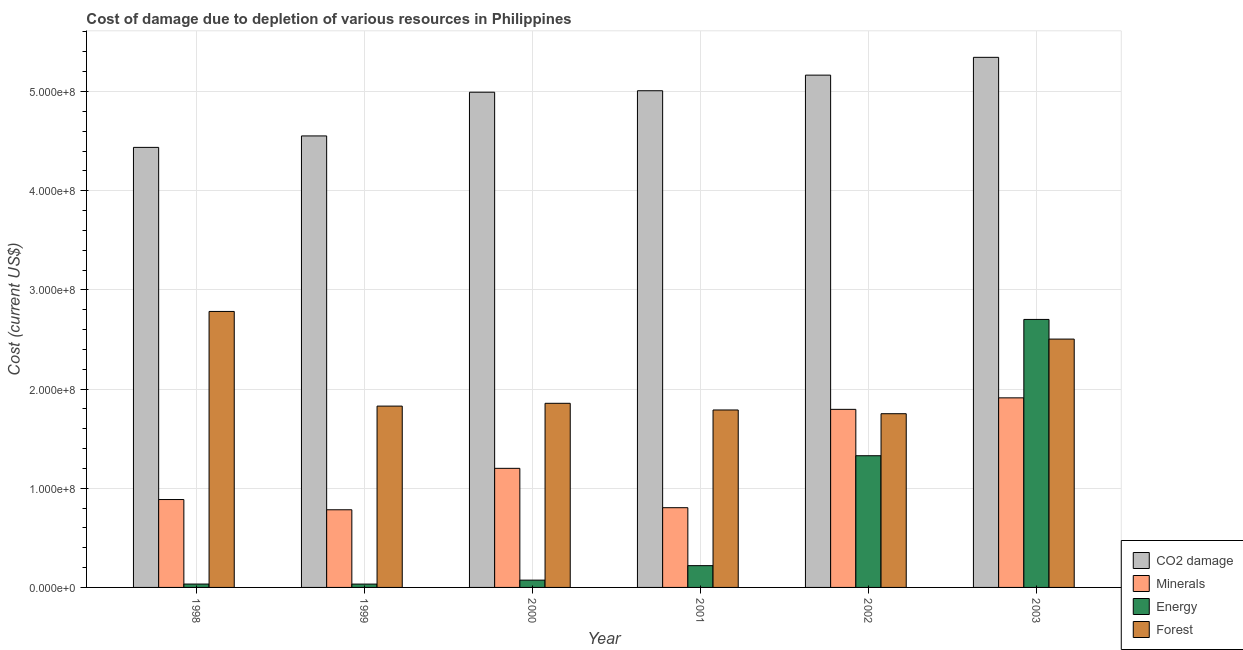How many different coloured bars are there?
Your answer should be very brief. 4. How many bars are there on the 2nd tick from the left?
Your answer should be compact. 4. What is the cost of damage due to depletion of coal in 2002?
Make the answer very short. 5.16e+08. Across all years, what is the maximum cost of damage due to depletion of energy?
Ensure brevity in your answer.  2.70e+08. Across all years, what is the minimum cost of damage due to depletion of coal?
Offer a terse response. 4.44e+08. In which year was the cost of damage due to depletion of forests minimum?
Your answer should be compact. 2002. What is the total cost of damage due to depletion of coal in the graph?
Your answer should be compact. 2.95e+09. What is the difference between the cost of damage due to depletion of forests in 2002 and that in 2003?
Offer a terse response. -7.52e+07. What is the difference between the cost of damage due to depletion of forests in 2003 and the cost of damage due to depletion of energy in 1998?
Provide a succinct answer. -2.79e+07. What is the average cost of damage due to depletion of coal per year?
Give a very brief answer. 4.92e+08. What is the ratio of the cost of damage due to depletion of coal in 2001 to that in 2002?
Your answer should be compact. 0.97. Is the cost of damage due to depletion of forests in 1998 less than that in 2003?
Give a very brief answer. No. Is the difference between the cost of damage due to depletion of forests in 2001 and 2002 greater than the difference between the cost of damage due to depletion of coal in 2001 and 2002?
Provide a short and direct response. No. What is the difference between the highest and the second highest cost of damage due to depletion of minerals?
Provide a succinct answer. 1.16e+07. What is the difference between the highest and the lowest cost of damage due to depletion of coal?
Your answer should be very brief. 9.08e+07. In how many years, is the cost of damage due to depletion of coal greater than the average cost of damage due to depletion of coal taken over all years?
Provide a short and direct response. 4. What does the 3rd bar from the left in 1999 represents?
Ensure brevity in your answer.  Energy. What does the 3rd bar from the right in 2001 represents?
Your answer should be compact. Minerals. Is it the case that in every year, the sum of the cost of damage due to depletion of coal and cost of damage due to depletion of minerals is greater than the cost of damage due to depletion of energy?
Your answer should be compact. Yes. Are the values on the major ticks of Y-axis written in scientific E-notation?
Your response must be concise. Yes. How are the legend labels stacked?
Keep it short and to the point. Vertical. What is the title of the graph?
Ensure brevity in your answer.  Cost of damage due to depletion of various resources in Philippines . Does "Fiscal policy" appear as one of the legend labels in the graph?
Keep it short and to the point. No. What is the label or title of the X-axis?
Provide a succinct answer. Year. What is the label or title of the Y-axis?
Keep it short and to the point. Cost (current US$). What is the Cost (current US$) in CO2 damage in 1998?
Offer a very short reply. 4.44e+08. What is the Cost (current US$) of Minerals in 1998?
Make the answer very short. 8.86e+07. What is the Cost (current US$) in Energy in 1998?
Your answer should be very brief. 3.40e+06. What is the Cost (current US$) of Forest in 1998?
Your response must be concise. 2.78e+08. What is the Cost (current US$) in CO2 damage in 1999?
Provide a short and direct response. 4.55e+08. What is the Cost (current US$) of Minerals in 1999?
Offer a very short reply. 7.83e+07. What is the Cost (current US$) in Energy in 1999?
Offer a very short reply. 3.37e+06. What is the Cost (current US$) of Forest in 1999?
Offer a terse response. 1.83e+08. What is the Cost (current US$) of CO2 damage in 2000?
Your response must be concise. 4.99e+08. What is the Cost (current US$) of Minerals in 2000?
Keep it short and to the point. 1.20e+08. What is the Cost (current US$) of Energy in 2000?
Provide a short and direct response. 7.35e+06. What is the Cost (current US$) of Forest in 2000?
Your response must be concise. 1.86e+08. What is the Cost (current US$) of CO2 damage in 2001?
Provide a short and direct response. 5.01e+08. What is the Cost (current US$) in Minerals in 2001?
Provide a succinct answer. 8.04e+07. What is the Cost (current US$) in Energy in 2001?
Ensure brevity in your answer.  2.20e+07. What is the Cost (current US$) in Forest in 2001?
Your answer should be compact. 1.79e+08. What is the Cost (current US$) of CO2 damage in 2002?
Offer a terse response. 5.16e+08. What is the Cost (current US$) of Minerals in 2002?
Ensure brevity in your answer.  1.80e+08. What is the Cost (current US$) in Energy in 2002?
Your answer should be very brief. 1.33e+08. What is the Cost (current US$) of Forest in 2002?
Provide a short and direct response. 1.75e+08. What is the Cost (current US$) in CO2 damage in 2003?
Keep it short and to the point. 5.34e+08. What is the Cost (current US$) of Minerals in 2003?
Your response must be concise. 1.91e+08. What is the Cost (current US$) of Energy in 2003?
Your response must be concise. 2.70e+08. What is the Cost (current US$) in Forest in 2003?
Keep it short and to the point. 2.50e+08. Across all years, what is the maximum Cost (current US$) in CO2 damage?
Keep it short and to the point. 5.34e+08. Across all years, what is the maximum Cost (current US$) in Minerals?
Offer a terse response. 1.91e+08. Across all years, what is the maximum Cost (current US$) in Energy?
Ensure brevity in your answer.  2.70e+08. Across all years, what is the maximum Cost (current US$) in Forest?
Your answer should be compact. 2.78e+08. Across all years, what is the minimum Cost (current US$) of CO2 damage?
Provide a short and direct response. 4.44e+08. Across all years, what is the minimum Cost (current US$) in Minerals?
Make the answer very short. 7.83e+07. Across all years, what is the minimum Cost (current US$) of Energy?
Give a very brief answer. 3.37e+06. Across all years, what is the minimum Cost (current US$) in Forest?
Offer a terse response. 1.75e+08. What is the total Cost (current US$) of CO2 damage in the graph?
Make the answer very short. 2.95e+09. What is the total Cost (current US$) of Minerals in the graph?
Keep it short and to the point. 7.38e+08. What is the total Cost (current US$) of Energy in the graph?
Ensure brevity in your answer.  4.39e+08. What is the total Cost (current US$) in Forest in the graph?
Provide a short and direct response. 1.25e+09. What is the difference between the Cost (current US$) of CO2 damage in 1998 and that in 1999?
Keep it short and to the point. -1.16e+07. What is the difference between the Cost (current US$) in Minerals in 1998 and that in 1999?
Provide a short and direct response. 1.03e+07. What is the difference between the Cost (current US$) of Energy in 1998 and that in 1999?
Your answer should be very brief. 3.30e+04. What is the difference between the Cost (current US$) of Forest in 1998 and that in 1999?
Provide a short and direct response. 9.54e+07. What is the difference between the Cost (current US$) of CO2 damage in 1998 and that in 2000?
Ensure brevity in your answer.  -5.56e+07. What is the difference between the Cost (current US$) of Minerals in 1998 and that in 2000?
Ensure brevity in your answer.  -3.15e+07. What is the difference between the Cost (current US$) of Energy in 1998 and that in 2000?
Offer a terse response. -3.95e+06. What is the difference between the Cost (current US$) of Forest in 1998 and that in 2000?
Your answer should be very brief. 9.26e+07. What is the difference between the Cost (current US$) in CO2 damage in 1998 and that in 2001?
Keep it short and to the point. -5.71e+07. What is the difference between the Cost (current US$) in Minerals in 1998 and that in 2001?
Your answer should be very brief. 8.23e+06. What is the difference between the Cost (current US$) of Energy in 1998 and that in 2001?
Give a very brief answer. -1.86e+07. What is the difference between the Cost (current US$) of Forest in 1998 and that in 2001?
Offer a very short reply. 9.93e+07. What is the difference between the Cost (current US$) in CO2 damage in 1998 and that in 2002?
Make the answer very short. -7.28e+07. What is the difference between the Cost (current US$) of Minerals in 1998 and that in 2002?
Ensure brevity in your answer.  -9.09e+07. What is the difference between the Cost (current US$) in Energy in 1998 and that in 2002?
Offer a terse response. -1.29e+08. What is the difference between the Cost (current US$) of Forest in 1998 and that in 2002?
Your answer should be compact. 1.03e+08. What is the difference between the Cost (current US$) of CO2 damage in 1998 and that in 2003?
Provide a succinct answer. -9.08e+07. What is the difference between the Cost (current US$) in Minerals in 1998 and that in 2003?
Provide a succinct answer. -1.03e+08. What is the difference between the Cost (current US$) of Energy in 1998 and that in 2003?
Provide a succinct answer. -2.67e+08. What is the difference between the Cost (current US$) in Forest in 1998 and that in 2003?
Your response must be concise. 2.79e+07. What is the difference between the Cost (current US$) of CO2 damage in 1999 and that in 2000?
Give a very brief answer. -4.41e+07. What is the difference between the Cost (current US$) in Minerals in 1999 and that in 2000?
Your answer should be very brief. -4.18e+07. What is the difference between the Cost (current US$) in Energy in 1999 and that in 2000?
Provide a succinct answer. -3.98e+06. What is the difference between the Cost (current US$) of Forest in 1999 and that in 2000?
Ensure brevity in your answer.  -2.81e+06. What is the difference between the Cost (current US$) in CO2 damage in 1999 and that in 2001?
Offer a terse response. -4.56e+07. What is the difference between the Cost (current US$) in Minerals in 1999 and that in 2001?
Offer a very short reply. -2.09e+06. What is the difference between the Cost (current US$) of Energy in 1999 and that in 2001?
Your response must be concise. -1.86e+07. What is the difference between the Cost (current US$) in Forest in 1999 and that in 2001?
Your response must be concise. 3.92e+06. What is the difference between the Cost (current US$) of CO2 damage in 1999 and that in 2002?
Offer a terse response. -6.13e+07. What is the difference between the Cost (current US$) in Minerals in 1999 and that in 2002?
Offer a terse response. -1.01e+08. What is the difference between the Cost (current US$) of Energy in 1999 and that in 2002?
Your response must be concise. -1.29e+08. What is the difference between the Cost (current US$) in Forest in 1999 and that in 2002?
Offer a terse response. 7.68e+06. What is the difference between the Cost (current US$) of CO2 damage in 1999 and that in 2003?
Give a very brief answer. -7.92e+07. What is the difference between the Cost (current US$) in Minerals in 1999 and that in 2003?
Provide a short and direct response. -1.13e+08. What is the difference between the Cost (current US$) of Energy in 1999 and that in 2003?
Ensure brevity in your answer.  -2.67e+08. What is the difference between the Cost (current US$) of Forest in 1999 and that in 2003?
Provide a short and direct response. -6.76e+07. What is the difference between the Cost (current US$) of CO2 damage in 2000 and that in 2001?
Keep it short and to the point. -1.48e+06. What is the difference between the Cost (current US$) in Minerals in 2000 and that in 2001?
Your response must be concise. 3.97e+07. What is the difference between the Cost (current US$) in Energy in 2000 and that in 2001?
Your answer should be compact. -1.46e+07. What is the difference between the Cost (current US$) in Forest in 2000 and that in 2001?
Make the answer very short. 6.73e+06. What is the difference between the Cost (current US$) in CO2 damage in 2000 and that in 2002?
Give a very brief answer. -1.72e+07. What is the difference between the Cost (current US$) in Minerals in 2000 and that in 2002?
Your answer should be very brief. -5.95e+07. What is the difference between the Cost (current US$) of Energy in 2000 and that in 2002?
Your response must be concise. -1.25e+08. What is the difference between the Cost (current US$) of Forest in 2000 and that in 2002?
Your answer should be very brief. 1.05e+07. What is the difference between the Cost (current US$) of CO2 damage in 2000 and that in 2003?
Offer a terse response. -3.52e+07. What is the difference between the Cost (current US$) of Minerals in 2000 and that in 2003?
Give a very brief answer. -7.11e+07. What is the difference between the Cost (current US$) in Energy in 2000 and that in 2003?
Provide a succinct answer. -2.63e+08. What is the difference between the Cost (current US$) in Forest in 2000 and that in 2003?
Provide a succinct answer. -6.47e+07. What is the difference between the Cost (current US$) of CO2 damage in 2001 and that in 2002?
Provide a succinct answer. -1.57e+07. What is the difference between the Cost (current US$) in Minerals in 2001 and that in 2002?
Your answer should be compact. -9.92e+07. What is the difference between the Cost (current US$) of Energy in 2001 and that in 2002?
Offer a very short reply. -1.11e+08. What is the difference between the Cost (current US$) of Forest in 2001 and that in 2002?
Offer a very short reply. 3.76e+06. What is the difference between the Cost (current US$) in CO2 damage in 2001 and that in 2003?
Make the answer very short. -3.37e+07. What is the difference between the Cost (current US$) of Minerals in 2001 and that in 2003?
Offer a terse response. -1.11e+08. What is the difference between the Cost (current US$) in Energy in 2001 and that in 2003?
Offer a terse response. -2.48e+08. What is the difference between the Cost (current US$) of Forest in 2001 and that in 2003?
Your answer should be very brief. -7.15e+07. What is the difference between the Cost (current US$) in CO2 damage in 2002 and that in 2003?
Your answer should be very brief. -1.79e+07. What is the difference between the Cost (current US$) of Minerals in 2002 and that in 2003?
Ensure brevity in your answer.  -1.16e+07. What is the difference between the Cost (current US$) of Energy in 2002 and that in 2003?
Ensure brevity in your answer.  -1.37e+08. What is the difference between the Cost (current US$) in Forest in 2002 and that in 2003?
Give a very brief answer. -7.52e+07. What is the difference between the Cost (current US$) of CO2 damage in 1998 and the Cost (current US$) of Minerals in 1999?
Your answer should be compact. 3.65e+08. What is the difference between the Cost (current US$) in CO2 damage in 1998 and the Cost (current US$) in Energy in 1999?
Provide a short and direct response. 4.40e+08. What is the difference between the Cost (current US$) in CO2 damage in 1998 and the Cost (current US$) in Forest in 1999?
Provide a succinct answer. 2.61e+08. What is the difference between the Cost (current US$) in Minerals in 1998 and the Cost (current US$) in Energy in 1999?
Offer a terse response. 8.52e+07. What is the difference between the Cost (current US$) of Minerals in 1998 and the Cost (current US$) of Forest in 1999?
Your response must be concise. -9.42e+07. What is the difference between the Cost (current US$) in Energy in 1998 and the Cost (current US$) in Forest in 1999?
Give a very brief answer. -1.79e+08. What is the difference between the Cost (current US$) in CO2 damage in 1998 and the Cost (current US$) in Minerals in 2000?
Keep it short and to the point. 3.24e+08. What is the difference between the Cost (current US$) of CO2 damage in 1998 and the Cost (current US$) of Energy in 2000?
Make the answer very short. 4.36e+08. What is the difference between the Cost (current US$) in CO2 damage in 1998 and the Cost (current US$) in Forest in 2000?
Your answer should be very brief. 2.58e+08. What is the difference between the Cost (current US$) in Minerals in 1998 and the Cost (current US$) in Energy in 2000?
Offer a terse response. 8.13e+07. What is the difference between the Cost (current US$) of Minerals in 1998 and the Cost (current US$) of Forest in 2000?
Your answer should be compact. -9.70e+07. What is the difference between the Cost (current US$) in Energy in 1998 and the Cost (current US$) in Forest in 2000?
Make the answer very short. -1.82e+08. What is the difference between the Cost (current US$) in CO2 damage in 1998 and the Cost (current US$) in Minerals in 2001?
Your response must be concise. 3.63e+08. What is the difference between the Cost (current US$) in CO2 damage in 1998 and the Cost (current US$) in Energy in 2001?
Give a very brief answer. 4.22e+08. What is the difference between the Cost (current US$) in CO2 damage in 1998 and the Cost (current US$) in Forest in 2001?
Keep it short and to the point. 2.65e+08. What is the difference between the Cost (current US$) in Minerals in 1998 and the Cost (current US$) in Energy in 2001?
Provide a succinct answer. 6.66e+07. What is the difference between the Cost (current US$) of Minerals in 1998 and the Cost (current US$) of Forest in 2001?
Offer a terse response. -9.03e+07. What is the difference between the Cost (current US$) of Energy in 1998 and the Cost (current US$) of Forest in 2001?
Offer a terse response. -1.75e+08. What is the difference between the Cost (current US$) of CO2 damage in 1998 and the Cost (current US$) of Minerals in 2002?
Offer a terse response. 2.64e+08. What is the difference between the Cost (current US$) of CO2 damage in 1998 and the Cost (current US$) of Energy in 2002?
Ensure brevity in your answer.  3.11e+08. What is the difference between the Cost (current US$) of CO2 damage in 1998 and the Cost (current US$) of Forest in 2002?
Your response must be concise. 2.69e+08. What is the difference between the Cost (current US$) of Minerals in 1998 and the Cost (current US$) of Energy in 2002?
Your answer should be very brief. -4.42e+07. What is the difference between the Cost (current US$) of Minerals in 1998 and the Cost (current US$) of Forest in 2002?
Provide a succinct answer. -8.65e+07. What is the difference between the Cost (current US$) of Energy in 1998 and the Cost (current US$) of Forest in 2002?
Keep it short and to the point. -1.72e+08. What is the difference between the Cost (current US$) of CO2 damage in 1998 and the Cost (current US$) of Minerals in 2003?
Provide a short and direct response. 2.53e+08. What is the difference between the Cost (current US$) in CO2 damage in 1998 and the Cost (current US$) in Energy in 2003?
Your answer should be compact. 1.73e+08. What is the difference between the Cost (current US$) of CO2 damage in 1998 and the Cost (current US$) of Forest in 2003?
Provide a succinct answer. 1.93e+08. What is the difference between the Cost (current US$) of Minerals in 1998 and the Cost (current US$) of Energy in 2003?
Offer a very short reply. -1.82e+08. What is the difference between the Cost (current US$) in Minerals in 1998 and the Cost (current US$) in Forest in 2003?
Provide a short and direct response. -1.62e+08. What is the difference between the Cost (current US$) in Energy in 1998 and the Cost (current US$) in Forest in 2003?
Your response must be concise. -2.47e+08. What is the difference between the Cost (current US$) of CO2 damage in 1999 and the Cost (current US$) of Minerals in 2000?
Your answer should be compact. 3.35e+08. What is the difference between the Cost (current US$) in CO2 damage in 1999 and the Cost (current US$) in Energy in 2000?
Your answer should be compact. 4.48e+08. What is the difference between the Cost (current US$) in CO2 damage in 1999 and the Cost (current US$) in Forest in 2000?
Keep it short and to the point. 2.70e+08. What is the difference between the Cost (current US$) in Minerals in 1999 and the Cost (current US$) in Energy in 2000?
Your answer should be compact. 7.09e+07. What is the difference between the Cost (current US$) of Minerals in 1999 and the Cost (current US$) of Forest in 2000?
Your response must be concise. -1.07e+08. What is the difference between the Cost (current US$) in Energy in 1999 and the Cost (current US$) in Forest in 2000?
Your response must be concise. -1.82e+08. What is the difference between the Cost (current US$) of CO2 damage in 1999 and the Cost (current US$) of Minerals in 2001?
Your response must be concise. 3.75e+08. What is the difference between the Cost (current US$) of CO2 damage in 1999 and the Cost (current US$) of Energy in 2001?
Offer a terse response. 4.33e+08. What is the difference between the Cost (current US$) of CO2 damage in 1999 and the Cost (current US$) of Forest in 2001?
Offer a terse response. 2.76e+08. What is the difference between the Cost (current US$) in Minerals in 1999 and the Cost (current US$) in Energy in 2001?
Provide a short and direct response. 5.63e+07. What is the difference between the Cost (current US$) of Minerals in 1999 and the Cost (current US$) of Forest in 2001?
Your response must be concise. -1.01e+08. What is the difference between the Cost (current US$) in Energy in 1999 and the Cost (current US$) in Forest in 2001?
Provide a succinct answer. -1.76e+08. What is the difference between the Cost (current US$) of CO2 damage in 1999 and the Cost (current US$) of Minerals in 2002?
Provide a succinct answer. 2.76e+08. What is the difference between the Cost (current US$) in CO2 damage in 1999 and the Cost (current US$) in Energy in 2002?
Your answer should be compact. 3.22e+08. What is the difference between the Cost (current US$) in CO2 damage in 1999 and the Cost (current US$) in Forest in 2002?
Offer a very short reply. 2.80e+08. What is the difference between the Cost (current US$) of Minerals in 1999 and the Cost (current US$) of Energy in 2002?
Give a very brief answer. -5.45e+07. What is the difference between the Cost (current US$) in Minerals in 1999 and the Cost (current US$) in Forest in 2002?
Offer a terse response. -9.69e+07. What is the difference between the Cost (current US$) of Energy in 1999 and the Cost (current US$) of Forest in 2002?
Provide a short and direct response. -1.72e+08. What is the difference between the Cost (current US$) of CO2 damage in 1999 and the Cost (current US$) of Minerals in 2003?
Ensure brevity in your answer.  2.64e+08. What is the difference between the Cost (current US$) of CO2 damage in 1999 and the Cost (current US$) of Energy in 2003?
Keep it short and to the point. 1.85e+08. What is the difference between the Cost (current US$) in CO2 damage in 1999 and the Cost (current US$) in Forest in 2003?
Your answer should be compact. 2.05e+08. What is the difference between the Cost (current US$) in Minerals in 1999 and the Cost (current US$) in Energy in 2003?
Offer a very short reply. -1.92e+08. What is the difference between the Cost (current US$) in Minerals in 1999 and the Cost (current US$) in Forest in 2003?
Ensure brevity in your answer.  -1.72e+08. What is the difference between the Cost (current US$) in Energy in 1999 and the Cost (current US$) in Forest in 2003?
Give a very brief answer. -2.47e+08. What is the difference between the Cost (current US$) in CO2 damage in 2000 and the Cost (current US$) in Minerals in 2001?
Keep it short and to the point. 4.19e+08. What is the difference between the Cost (current US$) in CO2 damage in 2000 and the Cost (current US$) in Energy in 2001?
Your response must be concise. 4.77e+08. What is the difference between the Cost (current US$) of CO2 damage in 2000 and the Cost (current US$) of Forest in 2001?
Offer a terse response. 3.20e+08. What is the difference between the Cost (current US$) in Minerals in 2000 and the Cost (current US$) in Energy in 2001?
Offer a very short reply. 9.81e+07. What is the difference between the Cost (current US$) in Minerals in 2000 and the Cost (current US$) in Forest in 2001?
Make the answer very short. -5.88e+07. What is the difference between the Cost (current US$) of Energy in 2000 and the Cost (current US$) of Forest in 2001?
Provide a succinct answer. -1.72e+08. What is the difference between the Cost (current US$) in CO2 damage in 2000 and the Cost (current US$) in Minerals in 2002?
Keep it short and to the point. 3.20e+08. What is the difference between the Cost (current US$) of CO2 damage in 2000 and the Cost (current US$) of Energy in 2002?
Your response must be concise. 3.66e+08. What is the difference between the Cost (current US$) in CO2 damage in 2000 and the Cost (current US$) in Forest in 2002?
Provide a short and direct response. 3.24e+08. What is the difference between the Cost (current US$) of Minerals in 2000 and the Cost (current US$) of Energy in 2002?
Make the answer very short. -1.27e+07. What is the difference between the Cost (current US$) in Minerals in 2000 and the Cost (current US$) in Forest in 2002?
Give a very brief answer. -5.51e+07. What is the difference between the Cost (current US$) in Energy in 2000 and the Cost (current US$) in Forest in 2002?
Your answer should be compact. -1.68e+08. What is the difference between the Cost (current US$) in CO2 damage in 2000 and the Cost (current US$) in Minerals in 2003?
Your answer should be very brief. 3.08e+08. What is the difference between the Cost (current US$) in CO2 damage in 2000 and the Cost (current US$) in Energy in 2003?
Make the answer very short. 2.29e+08. What is the difference between the Cost (current US$) of CO2 damage in 2000 and the Cost (current US$) of Forest in 2003?
Your answer should be very brief. 2.49e+08. What is the difference between the Cost (current US$) in Minerals in 2000 and the Cost (current US$) in Energy in 2003?
Keep it short and to the point. -1.50e+08. What is the difference between the Cost (current US$) in Minerals in 2000 and the Cost (current US$) in Forest in 2003?
Keep it short and to the point. -1.30e+08. What is the difference between the Cost (current US$) in Energy in 2000 and the Cost (current US$) in Forest in 2003?
Your response must be concise. -2.43e+08. What is the difference between the Cost (current US$) of CO2 damage in 2001 and the Cost (current US$) of Minerals in 2002?
Make the answer very short. 3.21e+08. What is the difference between the Cost (current US$) of CO2 damage in 2001 and the Cost (current US$) of Energy in 2002?
Ensure brevity in your answer.  3.68e+08. What is the difference between the Cost (current US$) of CO2 damage in 2001 and the Cost (current US$) of Forest in 2002?
Keep it short and to the point. 3.26e+08. What is the difference between the Cost (current US$) of Minerals in 2001 and the Cost (current US$) of Energy in 2002?
Give a very brief answer. -5.24e+07. What is the difference between the Cost (current US$) of Minerals in 2001 and the Cost (current US$) of Forest in 2002?
Your response must be concise. -9.48e+07. What is the difference between the Cost (current US$) in Energy in 2001 and the Cost (current US$) in Forest in 2002?
Make the answer very short. -1.53e+08. What is the difference between the Cost (current US$) of CO2 damage in 2001 and the Cost (current US$) of Minerals in 2003?
Offer a very short reply. 3.10e+08. What is the difference between the Cost (current US$) of CO2 damage in 2001 and the Cost (current US$) of Energy in 2003?
Ensure brevity in your answer.  2.31e+08. What is the difference between the Cost (current US$) of CO2 damage in 2001 and the Cost (current US$) of Forest in 2003?
Your answer should be very brief. 2.50e+08. What is the difference between the Cost (current US$) of Minerals in 2001 and the Cost (current US$) of Energy in 2003?
Provide a short and direct response. -1.90e+08. What is the difference between the Cost (current US$) in Minerals in 2001 and the Cost (current US$) in Forest in 2003?
Make the answer very short. -1.70e+08. What is the difference between the Cost (current US$) in Energy in 2001 and the Cost (current US$) in Forest in 2003?
Offer a terse response. -2.28e+08. What is the difference between the Cost (current US$) in CO2 damage in 2002 and the Cost (current US$) in Minerals in 2003?
Ensure brevity in your answer.  3.25e+08. What is the difference between the Cost (current US$) in CO2 damage in 2002 and the Cost (current US$) in Energy in 2003?
Your answer should be compact. 2.46e+08. What is the difference between the Cost (current US$) of CO2 damage in 2002 and the Cost (current US$) of Forest in 2003?
Give a very brief answer. 2.66e+08. What is the difference between the Cost (current US$) in Minerals in 2002 and the Cost (current US$) in Energy in 2003?
Make the answer very short. -9.07e+07. What is the difference between the Cost (current US$) of Minerals in 2002 and the Cost (current US$) of Forest in 2003?
Keep it short and to the point. -7.08e+07. What is the difference between the Cost (current US$) of Energy in 2002 and the Cost (current US$) of Forest in 2003?
Give a very brief answer. -1.18e+08. What is the average Cost (current US$) in CO2 damage per year?
Offer a terse response. 4.92e+08. What is the average Cost (current US$) of Minerals per year?
Provide a succinct answer. 1.23e+08. What is the average Cost (current US$) in Energy per year?
Ensure brevity in your answer.  7.32e+07. What is the average Cost (current US$) of Forest per year?
Ensure brevity in your answer.  2.09e+08. In the year 1998, what is the difference between the Cost (current US$) of CO2 damage and Cost (current US$) of Minerals?
Provide a succinct answer. 3.55e+08. In the year 1998, what is the difference between the Cost (current US$) of CO2 damage and Cost (current US$) of Energy?
Make the answer very short. 4.40e+08. In the year 1998, what is the difference between the Cost (current US$) of CO2 damage and Cost (current US$) of Forest?
Your answer should be compact. 1.65e+08. In the year 1998, what is the difference between the Cost (current US$) in Minerals and Cost (current US$) in Energy?
Provide a succinct answer. 8.52e+07. In the year 1998, what is the difference between the Cost (current US$) in Minerals and Cost (current US$) in Forest?
Provide a succinct answer. -1.90e+08. In the year 1998, what is the difference between the Cost (current US$) in Energy and Cost (current US$) in Forest?
Your answer should be compact. -2.75e+08. In the year 1999, what is the difference between the Cost (current US$) of CO2 damage and Cost (current US$) of Minerals?
Make the answer very short. 3.77e+08. In the year 1999, what is the difference between the Cost (current US$) in CO2 damage and Cost (current US$) in Energy?
Provide a succinct answer. 4.52e+08. In the year 1999, what is the difference between the Cost (current US$) of CO2 damage and Cost (current US$) of Forest?
Keep it short and to the point. 2.72e+08. In the year 1999, what is the difference between the Cost (current US$) in Minerals and Cost (current US$) in Energy?
Offer a terse response. 7.49e+07. In the year 1999, what is the difference between the Cost (current US$) of Minerals and Cost (current US$) of Forest?
Ensure brevity in your answer.  -1.05e+08. In the year 1999, what is the difference between the Cost (current US$) in Energy and Cost (current US$) in Forest?
Provide a succinct answer. -1.79e+08. In the year 2000, what is the difference between the Cost (current US$) of CO2 damage and Cost (current US$) of Minerals?
Offer a very short reply. 3.79e+08. In the year 2000, what is the difference between the Cost (current US$) in CO2 damage and Cost (current US$) in Energy?
Keep it short and to the point. 4.92e+08. In the year 2000, what is the difference between the Cost (current US$) in CO2 damage and Cost (current US$) in Forest?
Provide a succinct answer. 3.14e+08. In the year 2000, what is the difference between the Cost (current US$) in Minerals and Cost (current US$) in Energy?
Offer a terse response. 1.13e+08. In the year 2000, what is the difference between the Cost (current US$) of Minerals and Cost (current US$) of Forest?
Offer a very short reply. -6.56e+07. In the year 2000, what is the difference between the Cost (current US$) of Energy and Cost (current US$) of Forest?
Keep it short and to the point. -1.78e+08. In the year 2001, what is the difference between the Cost (current US$) in CO2 damage and Cost (current US$) in Minerals?
Give a very brief answer. 4.20e+08. In the year 2001, what is the difference between the Cost (current US$) in CO2 damage and Cost (current US$) in Energy?
Give a very brief answer. 4.79e+08. In the year 2001, what is the difference between the Cost (current US$) in CO2 damage and Cost (current US$) in Forest?
Your answer should be very brief. 3.22e+08. In the year 2001, what is the difference between the Cost (current US$) of Minerals and Cost (current US$) of Energy?
Your answer should be very brief. 5.84e+07. In the year 2001, what is the difference between the Cost (current US$) of Minerals and Cost (current US$) of Forest?
Your answer should be very brief. -9.85e+07. In the year 2001, what is the difference between the Cost (current US$) in Energy and Cost (current US$) in Forest?
Your response must be concise. -1.57e+08. In the year 2002, what is the difference between the Cost (current US$) in CO2 damage and Cost (current US$) in Minerals?
Keep it short and to the point. 3.37e+08. In the year 2002, what is the difference between the Cost (current US$) in CO2 damage and Cost (current US$) in Energy?
Keep it short and to the point. 3.84e+08. In the year 2002, what is the difference between the Cost (current US$) in CO2 damage and Cost (current US$) in Forest?
Your answer should be very brief. 3.41e+08. In the year 2002, what is the difference between the Cost (current US$) in Minerals and Cost (current US$) in Energy?
Offer a very short reply. 4.67e+07. In the year 2002, what is the difference between the Cost (current US$) of Minerals and Cost (current US$) of Forest?
Ensure brevity in your answer.  4.40e+06. In the year 2002, what is the difference between the Cost (current US$) of Energy and Cost (current US$) of Forest?
Give a very brief answer. -4.24e+07. In the year 2003, what is the difference between the Cost (current US$) in CO2 damage and Cost (current US$) in Minerals?
Keep it short and to the point. 3.43e+08. In the year 2003, what is the difference between the Cost (current US$) of CO2 damage and Cost (current US$) of Energy?
Provide a succinct answer. 2.64e+08. In the year 2003, what is the difference between the Cost (current US$) of CO2 damage and Cost (current US$) of Forest?
Provide a succinct answer. 2.84e+08. In the year 2003, what is the difference between the Cost (current US$) of Minerals and Cost (current US$) of Energy?
Make the answer very short. -7.91e+07. In the year 2003, what is the difference between the Cost (current US$) in Minerals and Cost (current US$) in Forest?
Provide a short and direct response. -5.92e+07. In the year 2003, what is the difference between the Cost (current US$) in Energy and Cost (current US$) in Forest?
Offer a very short reply. 1.98e+07. What is the ratio of the Cost (current US$) of CO2 damage in 1998 to that in 1999?
Your response must be concise. 0.97. What is the ratio of the Cost (current US$) in Minerals in 1998 to that in 1999?
Offer a terse response. 1.13. What is the ratio of the Cost (current US$) of Energy in 1998 to that in 1999?
Offer a terse response. 1.01. What is the ratio of the Cost (current US$) in Forest in 1998 to that in 1999?
Your answer should be very brief. 1.52. What is the ratio of the Cost (current US$) of CO2 damage in 1998 to that in 2000?
Provide a short and direct response. 0.89. What is the ratio of the Cost (current US$) in Minerals in 1998 to that in 2000?
Offer a very short reply. 0.74. What is the ratio of the Cost (current US$) in Energy in 1998 to that in 2000?
Provide a succinct answer. 0.46. What is the ratio of the Cost (current US$) in Forest in 1998 to that in 2000?
Offer a terse response. 1.5. What is the ratio of the Cost (current US$) of CO2 damage in 1998 to that in 2001?
Your response must be concise. 0.89. What is the ratio of the Cost (current US$) in Minerals in 1998 to that in 2001?
Provide a short and direct response. 1.1. What is the ratio of the Cost (current US$) in Energy in 1998 to that in 2001?
Your answer should be very brief. 0.15. What is the ratio of the Cost (current US$) of Forest in 1998 to that in 2001?
Keep it short and to the point. 1.56. What is the ratio of the Cost (current US$) in CO2 damage in 1998 to that in 2002?
Give a very brief answer. 0.86. What is the ratio of the Cost (current US$) of Minerals in 1998 to that in 2002?
Your answer should be compact. 0.49. What is the ratio of the Cost (current US$) of Energy in 1998 to that in 2002?
Provide a succinct answer. 0.03. What is the ratio of the Cost (current US$) of Forest in 1998 to that in 2002?
Offer a very short reply. 1.59. What is the ratio of the Cost (current US$) of CO2 damage in 1998 to that in 2003?
Offer a very short reply. 0.83. What is the ratio of the Cost (current US$) in Minerals in 1998 to that in 2003?
Provide a short and direct response. 0.46. What is the ratio of the Cost (current US$) in Energy in 1998 to that in 2003?
Keep it short and to the point. 0.01. What is the ratio of the Cost (current US$) of Forest in 1998 to that in 2003?
Your answer should be compact. 1.11. What is the ratio of the Cost (current US$) of CO2 damage in 1999 to that in 2000?
Give a very brief answer. 0.91. What is the ratio of the Cost (current US$) of Minerals in 1999 to that in 2000?
Give a very brief answer. 0.65. What is the ratio of the Cost (current US$) of Energy in 1999 to that in 2000?
Ensure brevity in your answer.  0.46. What is the ratio of the Cost (current US$) of Forest in 1999 to that in 2000?
Provide a short and direct response. 0.98. What is the ratio of the Cost (current US$) in CO2 damage in 1999 to that in 2001?
Ensure brevity in your answer.  0.91. What is the ratio of the Cost (current US$) in Minerals in 1999 to that in 2001?
Offer a terse response. 0.97. What is the ratio of the Cost (current US$) in Energy in 1999 to that in 2001?
Provide a succinct answer. 0.15. What is the ratio of the Cost (current US$) in Forest in 1999 to that in 2001?
Offer a terse response. 1.02. What is the ratio of the Cost (current US$) of CO2 damage in 1999 to that in 2002?
Give a very brief answer. 0.88. What is the ratio of the Cost (current US$) in Minerals in 1999 to that in 2002?
Offer a terse response. 0.44. What is the ratio of the Cost (current US$) in Energy in 1999 to that in 2002?
Offer a very short reply. 0.03. What is the ratio of the Cost (current US$) in Forest in 1999 to that in 2002?
Provide a short and direct response. 1.04. What is the ratio of the Cost (current US$) of CO2 damage in 1999 to that in 2003?
Your response must be concise. 0.85. What is the ratio of the Cost (current US$) of Minerals in 1999 to that in 2003?
Provide a short and direct response. 0.41. What is the ratio of the Cost (current US$) in Energy in 1999 to that in 2003?
Keep it short and to the point. 0.01. What is the ratio of the Cost (current US$) of Forest in 1999 to that in 2003?
Provide a succinct answer. 0.73. What is the ratio of the Cost (current US$) of Minerals in 2000 to that in 2001?
Your answer should be compact. 1.49. What is the ratio of the Cost (current US$) of Energy in 2000 to that in 2001?
Ensure brevity in your answer.  0.33. What is the ratio of the Cost (current US$) of Forest in 2000 to that in 2001?
Ensure brevity in your answer.  1.04. What is the ratio of the Cost (current US$) in CO2 damage in 2000 to that in 2002?
Ensure brevity in your answer.  0.97. What is the ratio of the Cost (current US$) of Minerals in 2000 to that in 2002?
Your answer should be very brief. 0.67. What is the ratio of the Cost (current US$) in Energy in 2000 to that in 2002?
Provide a short and direct response. 0.06. What is the ratio of the Cost (current US$) of Forest in 2000 to that in 2002?
Your answer should be compact. 1.06. What is the ratio of the Cost (current US$) of CO2 damage in 2000 to that in 2003?
Your response must be concise. 0.93. What is the ratio of the Cost (current US$) of Minerals in 2000 to that in 2003?
Your answer should be compact. 0.63. What is the ratio of the Cost (current US$) in Energy in 2000 to that in 2003?
Offer a very short reply. 0.03. What is the ratio of the Cost (current US$) of Forest in 2000 to that in 2003?
Provide a succinct answer. 0.74. What is the ratio of the Cost (current US$) in CO2 damage in 2001 to that in 2002?
Give a very brief answer. 0.97. What is the ratio of the Cost (current US$) of Minerals in 2001 to that in 2002?
Ensure brevity in your answer.  0.45. What is the ratio of the Cost (current US$) of Energy in 2001 to that in 2002?
Your answer should be very brief. 0.17. What is the ratio of the Cost (current US$) in Forest in 2001 to that in 2002?
Offer a very short reply. 1.02. What is the ratio of the Cost (current US$) of CO2 damage in 2001 to that in 2003?
Provide a succinct answer. 0.94. What is the ratio of the Cost (current US$) in Minerals in 2001 to that in 2003?
Ensure brevity in your answer.  0.42. What is the ratio of the Cost (current US$) of Energy in 2001 to that in 2003?
Offer a very short reply. 0.08. What is the ratio of the Cost (current US$) in Forest in 2001 to that in 2003?
Your answer should be very brief. 0.71. What is the ratio of the Cost (current US$) in CO2 damage in 2002 to that in 2003?
Your answer should be very brief. 0.97. What is the ratio of the Cost (current US$) of Minerals in 2002 to that in 2003?
Make the answer very short. 0.94. What is the ratio of the Cost (current US$) of Energy in 2002 to that in 2003?
Your answer should be very brief. 0.49. What is the ratio of the Cost (current US$) in Forest in 2002 to that in 2003?
Give a very brief answer. 0.7. What is the difference between the highest and the second highest Cost (current US$) in CO2 damage?
Provide a succinct answer. 1.79e+07. What is the difference between the highest and the second highest Cost (current US$) of Minerals?
Ensure brevity in your answer.  1.16e+07. What is the difference between the highest and the second highest Cost (current US$) of Energy?
Your answer should be compact. 1.37e+08. What is the difference between the highest and the second highest Cost (current US$) in Forest?
Your answer should be very brief. 2.79e+07. What is the difference between the highest and the lowest Cost (current US$) of CO2 damage?
Give a very brief answer. 9.08e+07. What is the difference between the highest and the lowest Cost (current US$) in Minerals?
Your answer should be very brief. 1.13e+08. What is the difference between the highest and the lowest Cost (current US$) in Energy?
Offer a very short reply. 2.67e+08. What is the difference between the highest and the lowest Cost (current US$) of Forest?
Ensure brevity in your answer.  1.03e+08. 